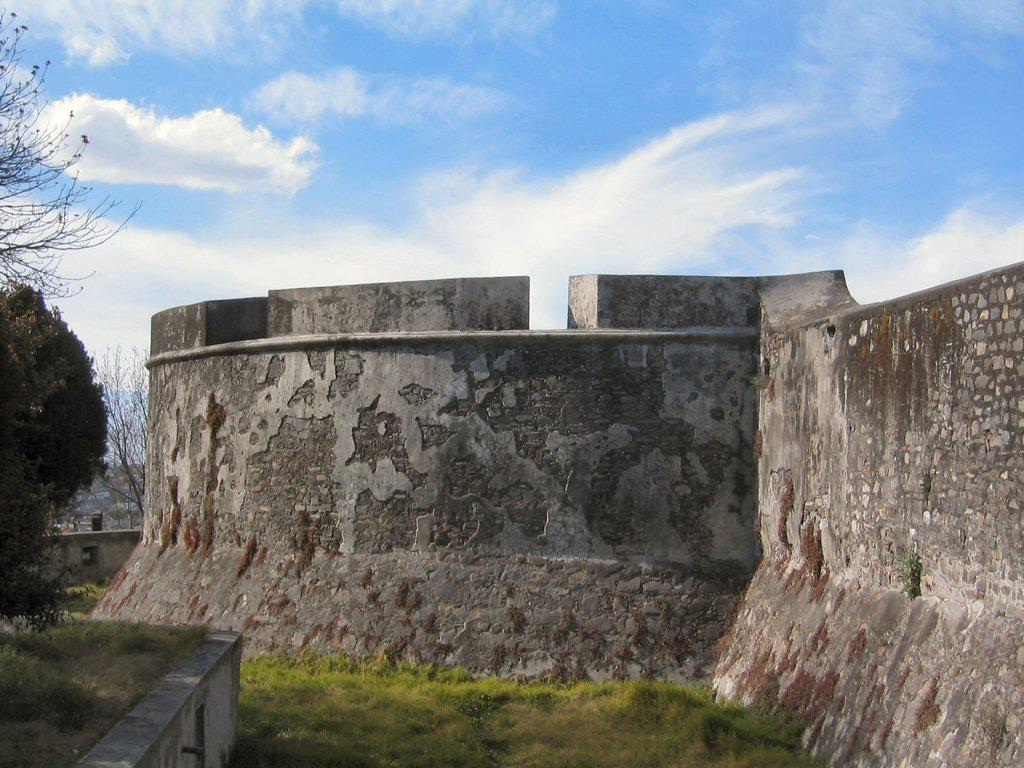What type of structure is in the image? There is a rock wall in the image. What is on the ground in front of the wall? Grass is present on the surface in front of the wall. What other natural elements can be seen in the image? There are trees in the image. What can be seen in the distance in the image? The sky is visible in the background of the image. What type of tub is hidden behind the rock wall in the image? There is no tub present in the image; it only features a rock wall, grass, trees, and the sky. 